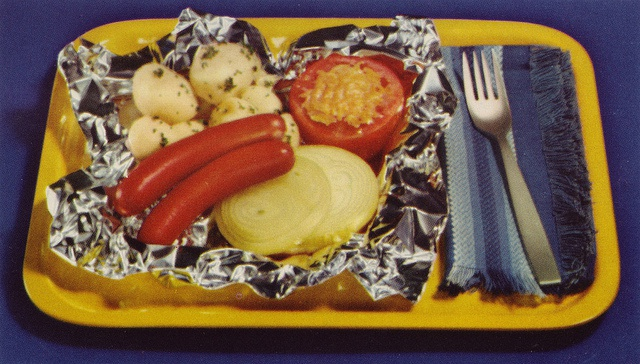Describe the objects in this image and their specific colors. I can see hot dog in navy, brown, and maroon tones, hot dog in navy, brown, and maroon tones, and fork in navy, tan, gray, and darkgray tones in this image. 